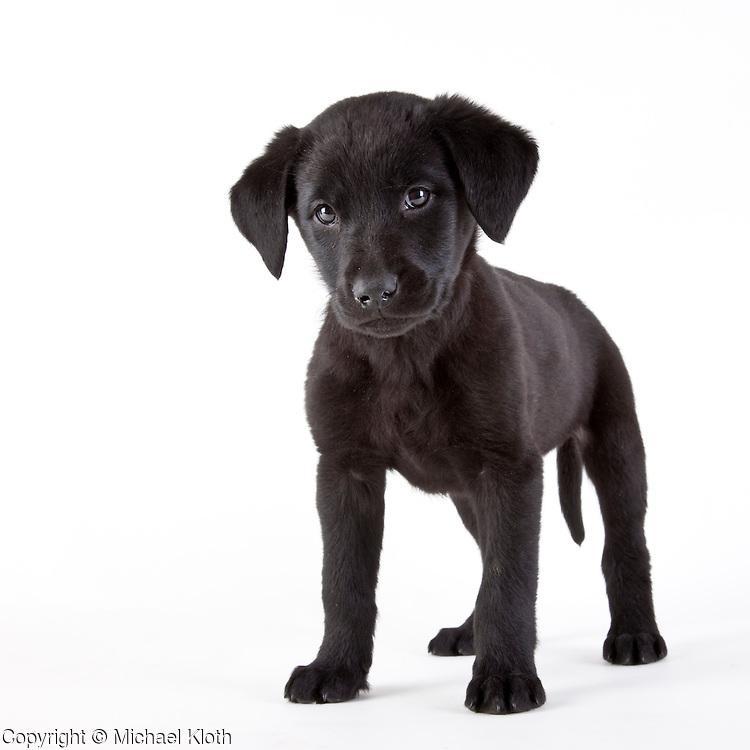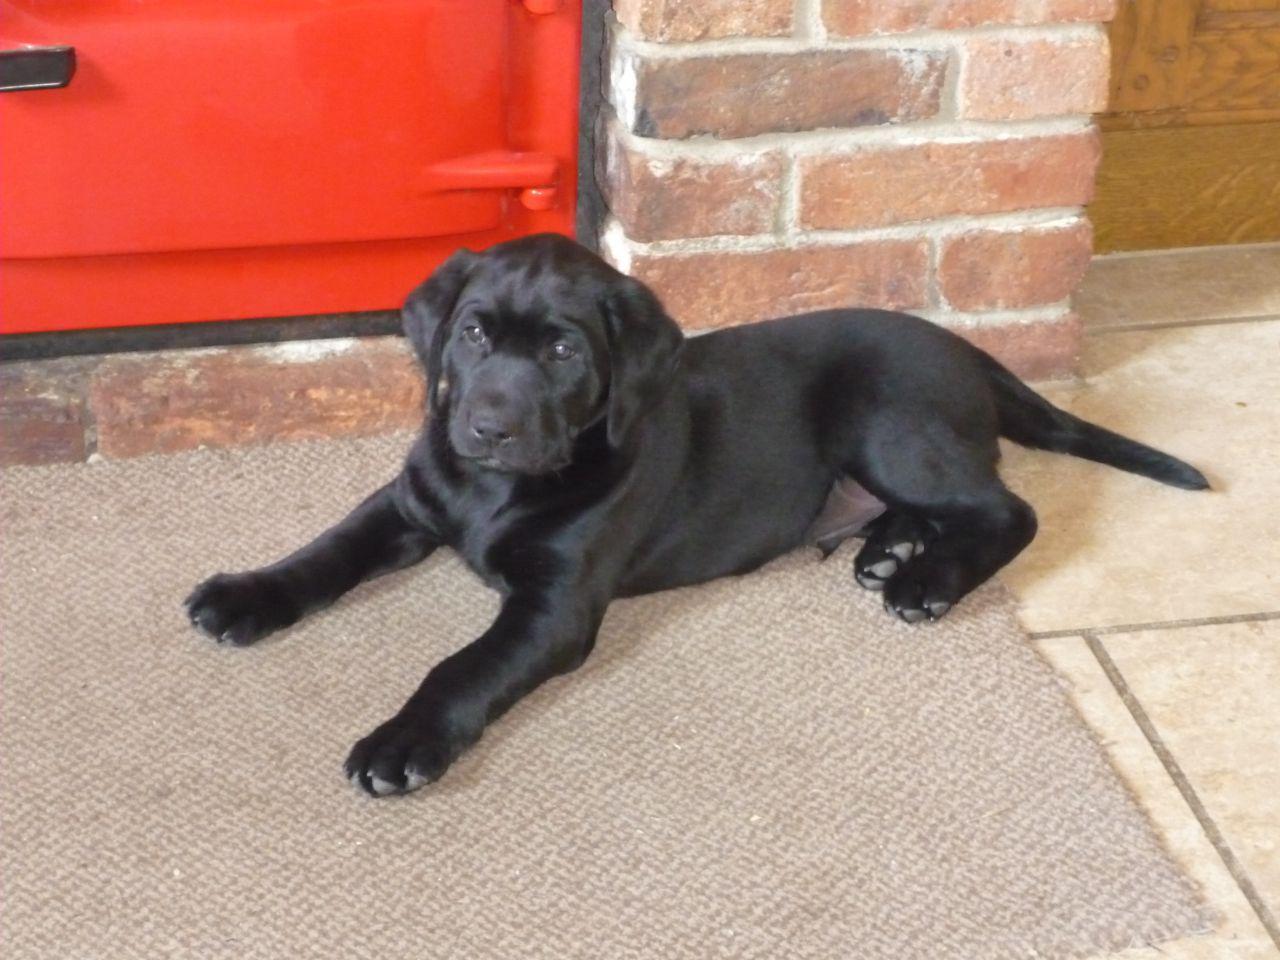The first image is the image on the left, the second image is the image on the right. Given the left and right images, does the statement "Both images contain the same number of puppies." hold true? Answer yes or no. Yes. 